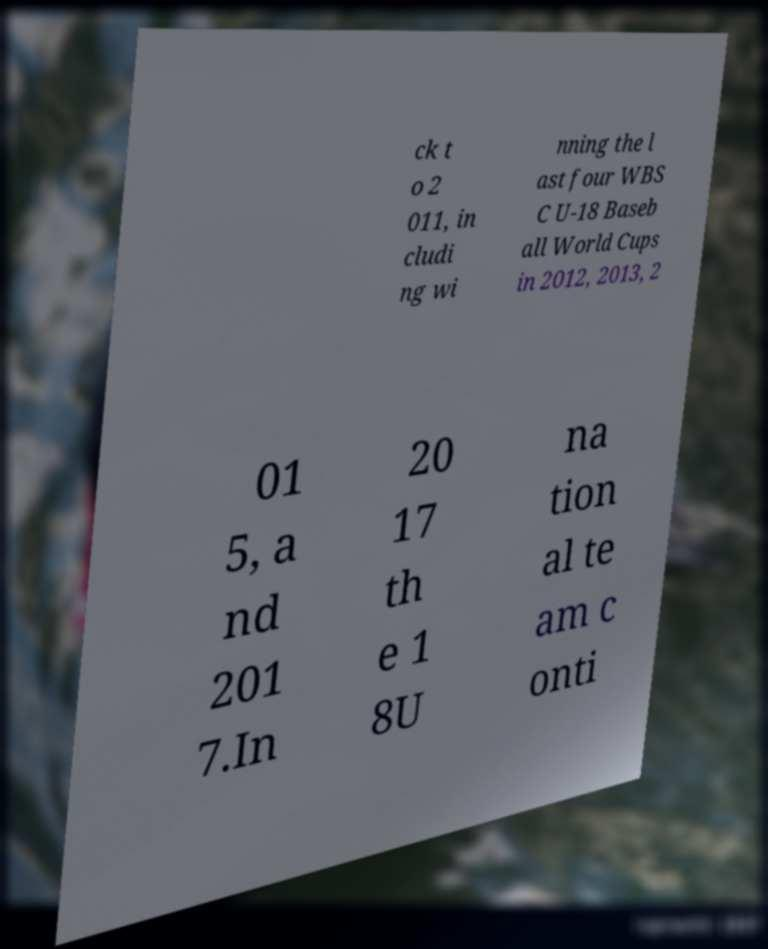For documentation purposes, I need the text within this image transcribed. Could you provide that? ck t o 2 011, in cludi ng wi nning the l ast four WBS C U-18 Baseb all World Cups in 2012, 2013, 2 01 5, a nd 201 7.In 20 17 th e 1 8U na tion al te am c onti 